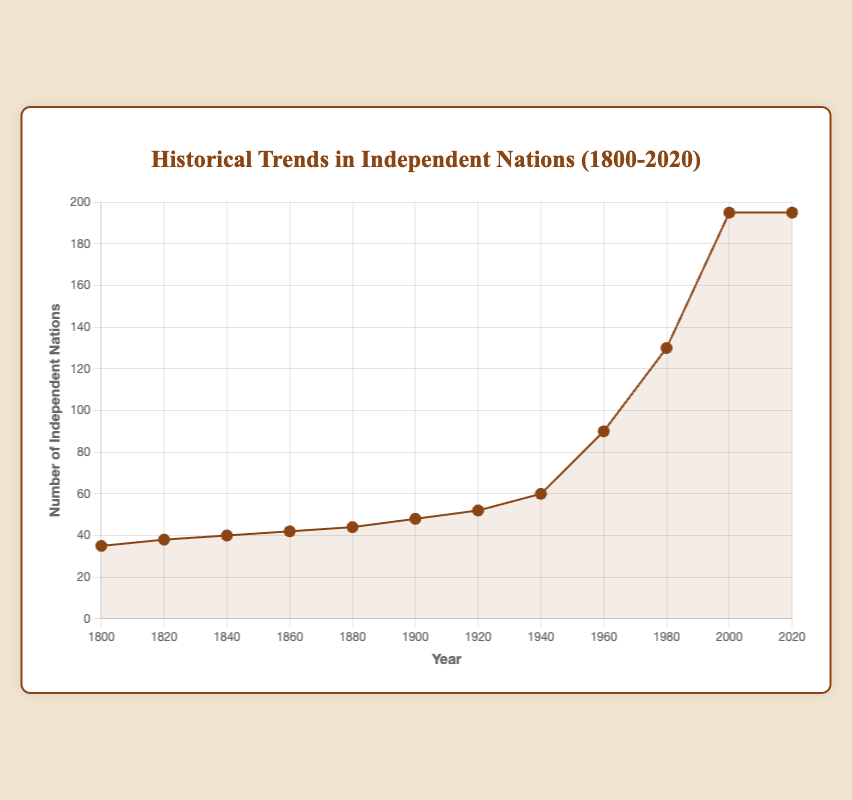What year had the steepest increase in the number of independent nations? To find the year with the steepest increase, we need to look for the largest vertical jump between two consecutive years on the line chart. The greatest increase appears between 1960 and 1980. The number of independent nations increased from 90 to 130, which is a jump of 40.
Answer: 1960 to 1980 How much did the number of independent nations increase between 1920 and 1960? Find the number of independent nations in 1920 (52) and in 1960 (90). Subtract 52 from 90.
Answer: 38 What is the average number of independent nations in the 19th century (1800-1899)? The years within the 19th century from the dataset are 1800, 1820, 1840, 1860, and 1880. The corresponding numbers of independent nations are 35, 38, 40, 42, and 44. Sum these numbers (35 + 38 + 40 + 42 + 44 = 199) and divide by 5.
Answer: 39.8 Is the number of independent nations in 1920 greater than in 1900? Compare the number of independent nations in 1920 (52) with 1900 (48).
Answer: Yes What was the total increase in the number of independent nations from 1800 to 2020? Find the number of independent nations in 1800 (35) and in 2020 (195). Subtract 35 from 195.
Answer: 160 In which year does the number of independent nations stay constant? Look for a flat line segment on the chart. The line is flat from 2000 to 2020.
Answer: 2000 to 2020 What is the difference in the number of independent nations between 1880 and 1980? Find the number of independent nations in 1880 (44) and in 1980 (130). Subtract 44 from 130.
Answer: 86 How does the number of independent nations in 1860 compare to 1940? Compare the number of independent nations in 1860 (42) with 1940 (60).
Answer: Less 